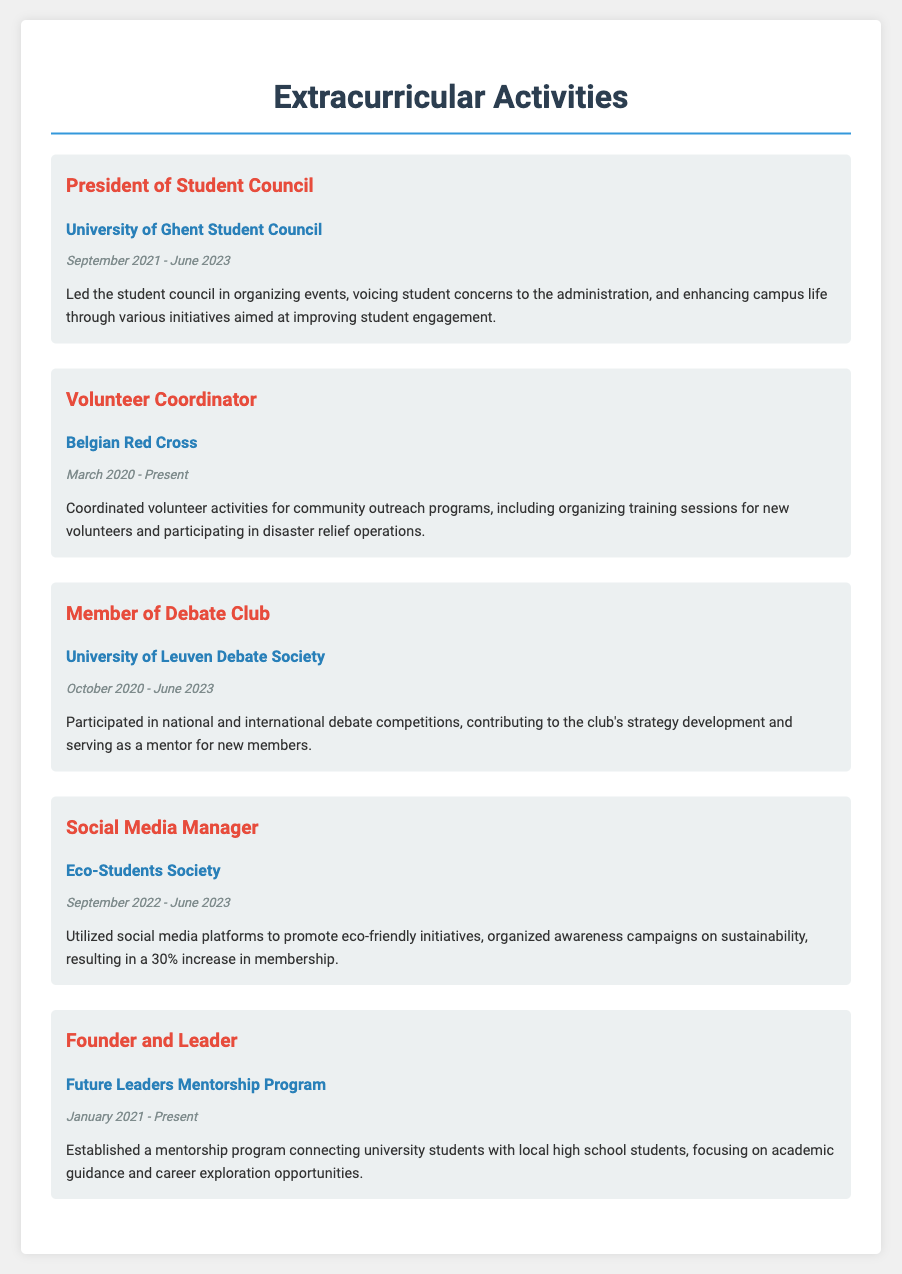what is the role held in the Student Council? The document specifies the role held as "President" in the Student Council.
Answer: President which organization did the Volunteer Coordinator role serve? The document indicates the organization as the "Belgian Red Cross."
Answer: Belgian Red Cross when did the social media management position start? The position started in "September 2022," as mentioned in the document.
Answer: September 2022 how long did the Future Leaders Mentorship Program run? The program started in "January 2021" and is currently ongoing, which makes it over 2 years long.
Answer: Over 2 years what type of activities did the Debate Club member participate in? The member participated in "national and international debate competitions."
Answer: Debate competitions which position involved organizing awareness campaigns? The role responsible for organizing awareness campaigns is the "Social Media Manager."
Answer: Social Media Manager who was involved in coordinating volunteer activities? The document states that the "Volunteer Coordinator" was involved in coordinating volunteer activities.
Answer: Volunteer Coordinator what was the outcome of the eco-friendly initiatives promotion? The promotion resulted in a "30% increase in membership."
Answer: 30% increase in membership what does the Future Leaders Mentorship Program focus on? The program focuses on "academic guidance and career exploration opportunities."
Answer: Academic guidance and career exploration 